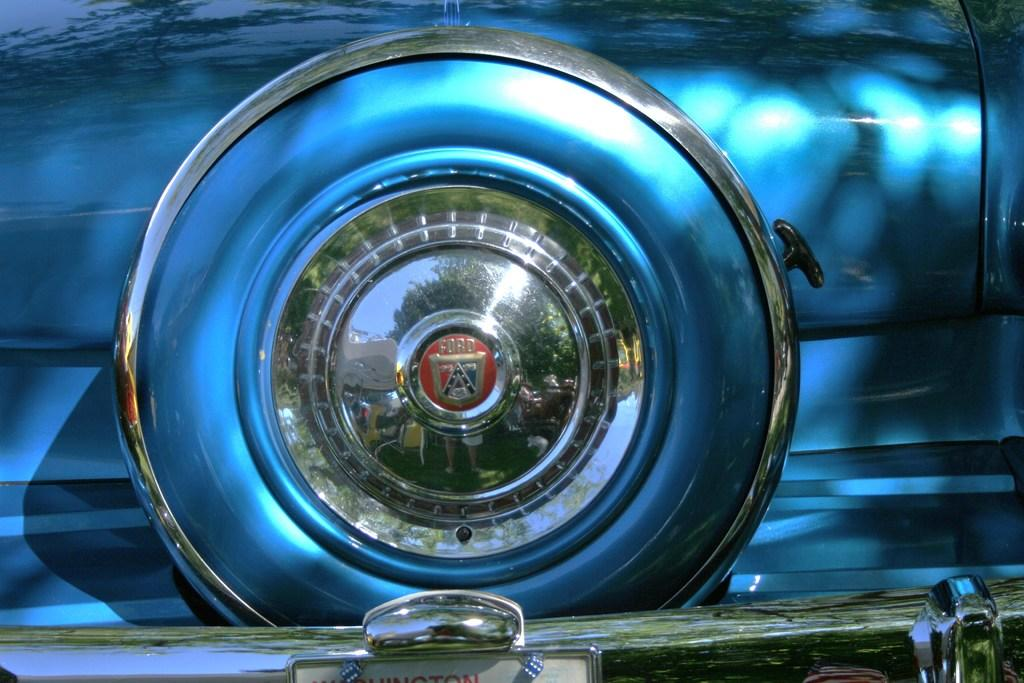What is the main subject of the image? There is a car in the image. Can you describe the color of the car? The car is blue. What part of the car is visible in the image? The headlights of the car are visible in the image. What type of wave can be seen crashing against the car in the image? There is no wave present in the image; it features a car with visible headlights. 